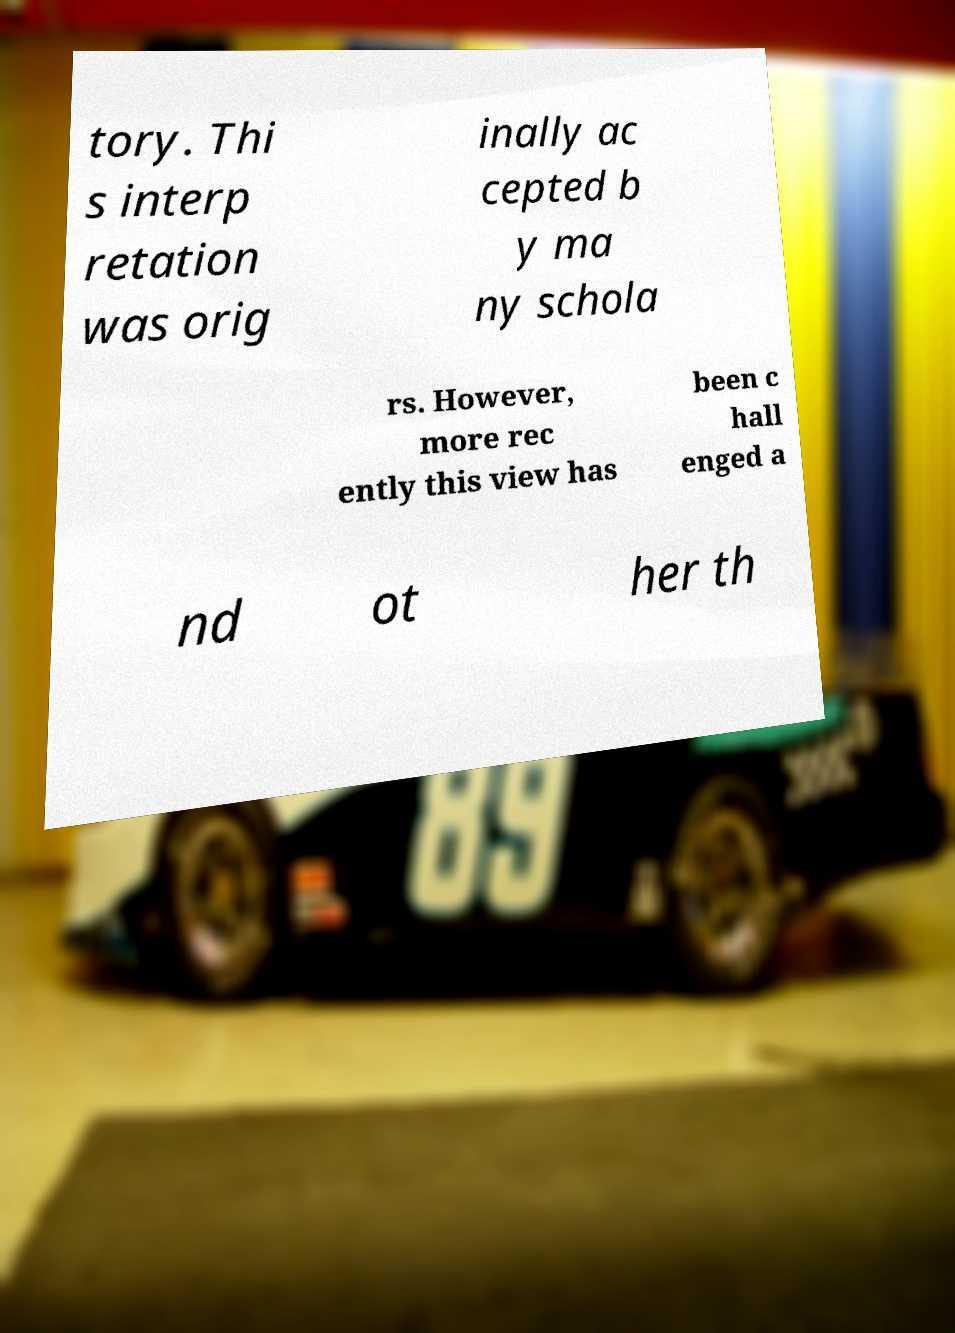Please identify and transcribe the text found in this image. tory. Thi s interp retation was orig inally ac cepted b y ma ny schola rs. However, more rec ently this view has been c hall enged a nd ot her th 